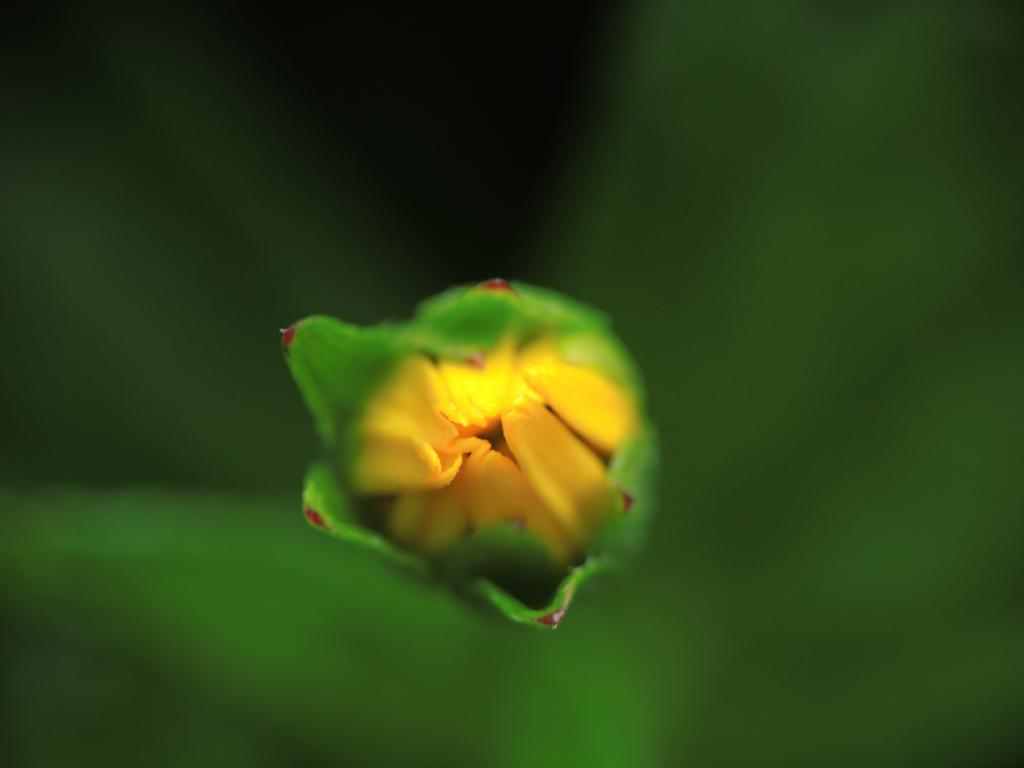What is the main subject of the image? There is a flower in the center of the image. Can you describe the background of the image? The background of the image is blurry. What type of cough can be heard coming from the bird in the image? There is no bird present in the image, and therefore no bird sounds can be heard. What is the bird writing on the flower in the image? There is no bird or writing present in the image. 